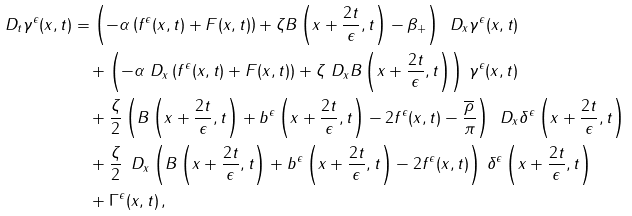<formula> <loc_0><loc_0><loc_500><loc_500>\ D _ { t } \gamma ^ { \epsilon } ( x , t ) & = \left ( - \alpha \left ( f ^ { \epsilon } ( x , t ) + F ( x , t ) \right ) + \zeta B \left ( x + \frac { 2 t } { \epsilon } , t \right ) - \beta _ { + } \right ) \, \ D _ { x } \gamma ^ { \epsilon } ( x , t ) \\ & \quad + \left ( - \alpha \ D _ { x } \left ( f ^ { \epsilon } ( x , t ) + F ( x , t ) \right ) + \zeta \ D _ { x } B \left ( x + \frac { 2 t } { \epsilon } , t \right ) \right ) \, \gamma ^ { \epsilon } ( x , t ) \\ & \quad + \frac { \zeta } { 2 } \left ( B \left ( x + \frac { 2 t } { \epsilon } , t \right ) + b ^ { \epsilon } \left ( x + \frac { 2 t } { \epsilon } , t \right ) - 2 f ^ { \epsilon } ( x , t ) - \frac { \overline { \rho } } { \pi } \right ) \, \ D _ { x } \delta ^ { \epsilon } \left ( x + \frac { 2 t } { \epsilon } , t \right ) \\ & \quad + \frac { \zeta } { 2 } \, \ D _ { x } \left ( B \left ( x + \frac { 2 t } { \epsilon } , t \right ) + b ^ { \epsilon } \left ( x + \frac { 2 t } { \epsilon } , t \right ) - 2 f ^ { \epsilon } ( x , t ) \right ) \, \delta ^ { \epsilon } \left ( x + \frac { 2 t } { \epsilon } , t \right ) \\ & \quad + \Gamma ^ { \epsilon } ( x , t ) \, ,</formula> 